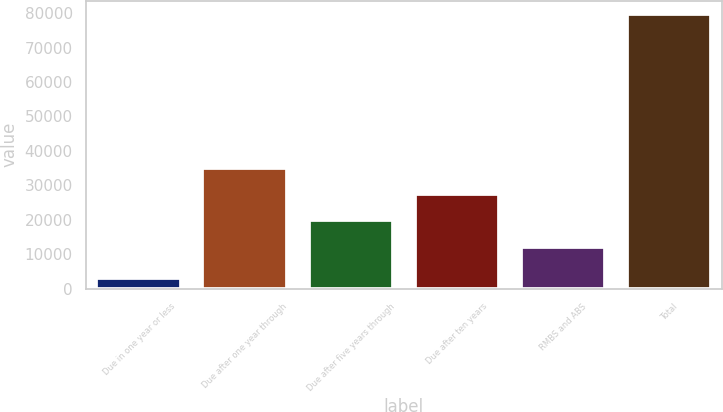Convert chart. <chart><loc_0><loc_0><loc_500><loc_500><bar_chart><fcel>Due in one year or less<fcel>Due after one year through<fcel>Due after five years through<fcel>Due after ten years<fcel>RMBS and ABS<fcel>Total<nl><fcel>3185<fcel>35165.1<fcel>19879.7<fcel>27522.4<fcel>12237<fcel>79612<nl></chart> 